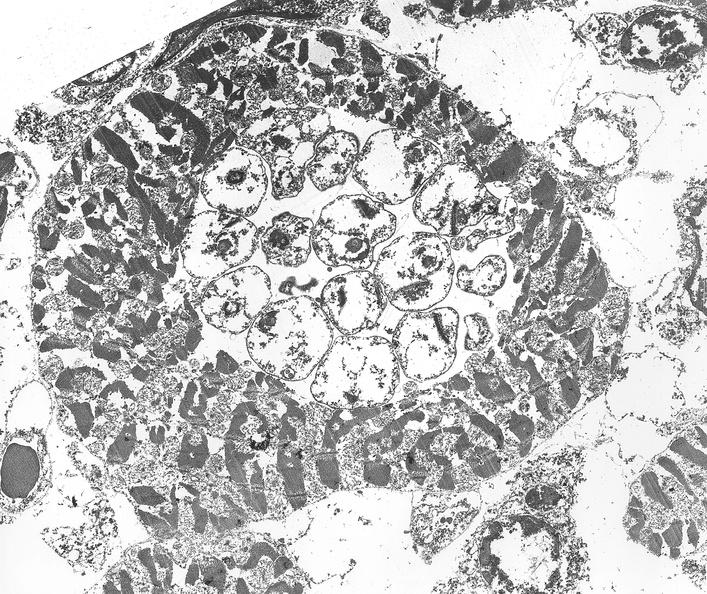does this image show chagas disease, acute, trypanasoma cruzi?
Answer the question using a single word or phrase. Yes 